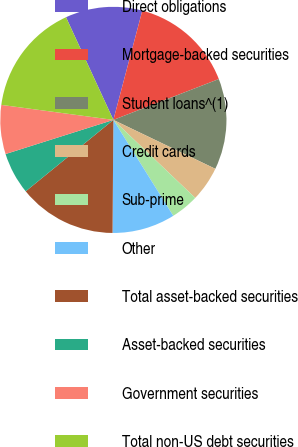<chart> <loc_0><loc_0><loc_500><loc_500><pie_chart><fcel>Direct obligations<fcel>Mortgage-backed securities<fcel>Student loans^(1)<fcel>Credit cards<fcel>Sub-prime<fcel>Other<fcel>Total asset-backed securities<fcel>Asset-backed securities<fcel>Government securities<fcel>Total non-US debt securities<nl><fcel>11.0%<fcel>15.0%<fcel>13.0%<fcel>5.0%<fcel>4.0%<fcel>9.0%<fcel>14.0%<fcel>6.0%<fcel>7.0%<fcel>16.0%<nl></chart> 